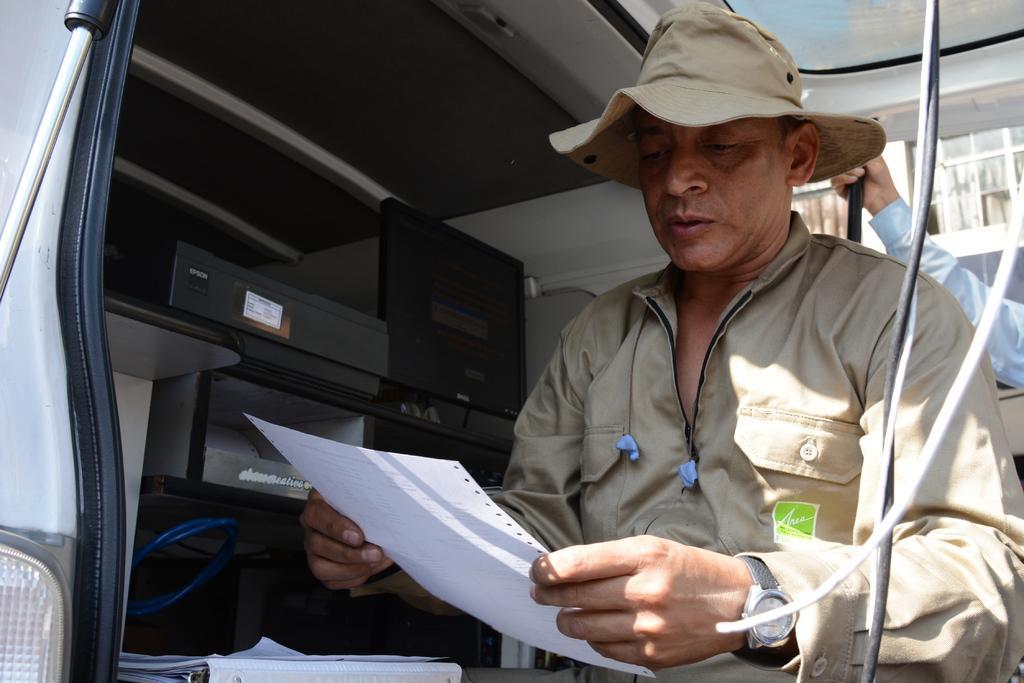Can you describe this image briefly? In this image there is a man with a hat and a paper and he is standing under the roof of a vehicle. In the vehicle there are papers, blue color wire, black color box and a monitor. In the background there is also some person. 